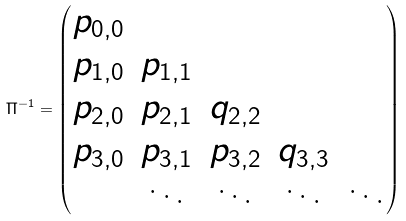<formula> <loc_0><loc_0><loc_500><loc_500>\Pi ^ { - 1 } = \begin{pmatrix} p _ { 0 , 0 } & & & \\ p _ { 1 , 0 } & p _ { 1 , 1 } & & \\ p _ { 2 , 0 } & p _ { 2 , 1 } & q _ { 2 , 2 } & \\ p _ { 3 , 0 } & p _ { 3 , 1 } & p _ { 3 , 2 } & q _ { 3 , 3 } & \\ & \ddots & \ddots & \ddots & \ddots \\ \end{pmatrix}</formula> 